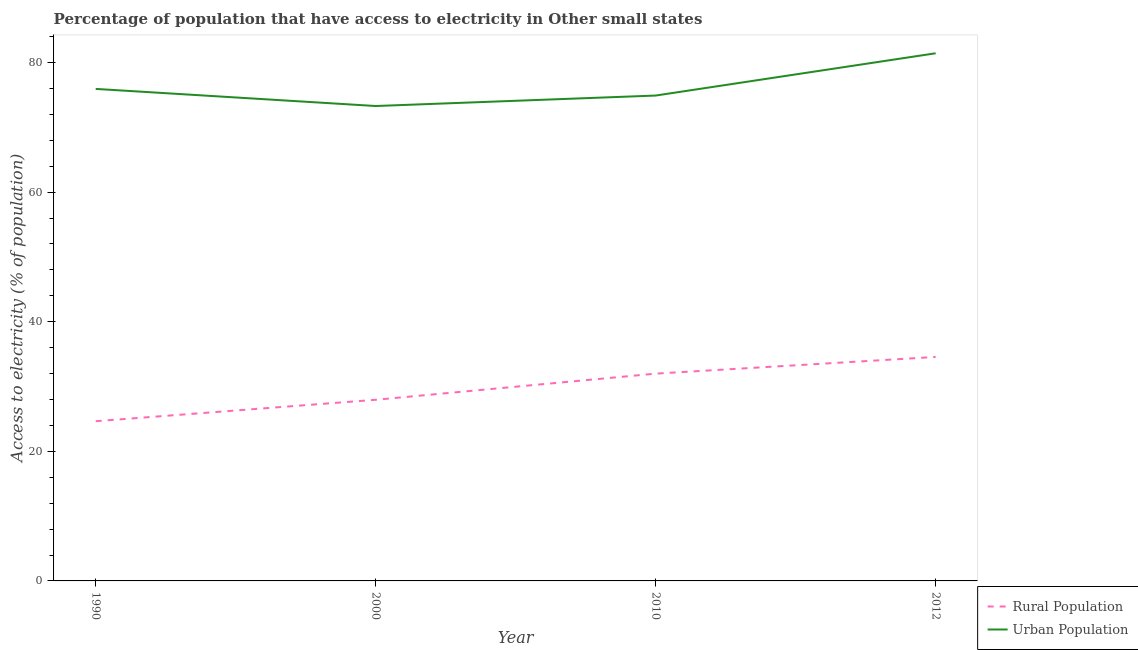Does the line corresponding to percentage of rural population having access to electricity intersect with the line corresponding to percentage of urban population having access to electricity?
Provide a succinct answer. No. Is the number of lines equal to the number of legend labels?
Ensure brevity in your answer.  Yes. What is the percentage of urban population having access to electricity in 2012?
Provide a succinct answer. 81.43. Across all years, what is the maximum percentage of rural population having access to electricity?
Provide a short and direct response. 34.57. Across all years, what is the minimum percentage of urban population having access to electricity?
Your answer should be very brief. 73.29. What is the total percentage of urban population having access to electricity in the graph?
Give a very brief answer. 305.56. What is the difference between the percentage of urban population having access to electricity in 1990 and that in 2010?
Give a very brief answer. 1.02. What is the difference between the percentage of urban population having access to electricity in 1990 and the percentage of rural population having access to electricity in 2012?
Provide a succinct answer. 41.36. What is the average percentage of urban population having access to electricity per year?
Offer a terse response. 76.39. In the year 2010, what is the difference between the percentage of rural population having access to electricity and percentage of urban population having access to electricity?
Your answer should be very brief. -42.92. What is the ratio of the percentage of urban population having access to electricity in 2000 to that in 2012?
Provide a short and direct response. 0.9. What is the difference between the highest and the second highest percentage of rural population having access to electricity?
Your answer should be very brief. 2.58. What is the difference between the highest and the lowest percentage of rural population having access to electricity?
Provide a succinct answer. 9.92. In how many years, is the percentage of rural population having access to electricity greater than the average percentage of rural population having access to electricity taken over all years?
Keep it short and to the point. 2. Is the sum of the percentage of rural population having access to electricity in 1990 and 2012 greater than the maximum percentage of urban population having access to electricity across all years?
Give a very brief answer. No. Does the percentage of urban population having access to electricity monotonically increase over the years?
Provide a succinct answer. No. Is the percentage of urban population having access to electricity strictly greater than the percentage of rural population having access to electricity over the years?
Ensure brevity in your answer.  Yes. Is the percentage of urban population having access to electricity strictly less than the percentage of rural population having access to electricity over the years?
Your answer should be compact. No. Does the graph contain any zero values?
Your answer should be compact. No. Does the graph contain grids?
Your answer should be compact. No. How many legend labels are there?
Your answer should be very brief. 2. How are the legend labels stacked?
Your answer should be very brief. Vertical. What is the title of the graph?
Provide a succinct answer. Percentage of population that have access to electricity in Other small states. What is the label or title of the Y-axis?
Your answer should be compact. Access to electricity (% of population). What is the Access to electricity (% of population) of Rural Population in 1990?
Provide a succinct answer. 24.65. What is the Access to electricity (% of population) of Urban Population in 1990?
Offer a very short reply. 75.93. What is the Access to electricity (% of population) in Rural Population in 2000?
Keep it short and to the point. 27.96. What is the Access to electricity (% of population) in Urban Population in 2000?
Give a very brief answer. 73.29. What is the Access to electricity (% of population) of Rural Population in 2010?
Keep it short and to the point. 31.99. What is the Access to electricity (% of population) of Urban Population in 2010?
Your response must be concise. 74.91. What is the Access to electricity (% of population) of Rural Population in 2012?
Keep it short and to the point. 34.57. What is the Access to electricity (% of population) in Urban Population in 2012?
Keep it short and to the point. 81.43. Across all years, what is the maximum Access to electricity (% of population) in Rural Population?
Ensure brevity in your answer.  34.57. Across all years, what is the maximum Access to electricity (% of population) of Urban Population?
Provide a succinct answer. 81.43. Across all years, what is the minimum Access to electricity (% of population) in Rural Population?
Make the answer very short. 24.65. Across all years, what is the minimum Access to electricity (% of population) of Urban Population?
Provide a short and direct response. 73.29. What is the total Access to electricity (% of population) of Rural Population in the graph?
Ensure brevity in your answer.  119.16. What is the total Access to electricity (% of population) in Urban Population in the graph?
Keep it short and to the point. 305.56. What is the difference between the Access to electricity (% of population) of Rural Population in 1990 and that in 2000?
Provide a short and direct response. -3.31. What is the difference between the Access to electricity (% of population) of Urban Population in 1990 and that in 2000?
Your response must be concise. 2.64. What is the difference between the Access to electricity (% of population) in Rural Population in 1990 and that in 2010?
Your answer should be very brief. -7.34. What is the difference between the Access to electricity (% of population) of Urban Population in 1990 and that in 2010?
Offer a terse response. 1.02. What is the difference between the Access to electricity (% of population) in Rural Population in 1990 and that in 2012?
Your answer should be compact. -9.92. What is the difference between the Access to electricity (% of population) of Urban Population in 1990 and that in 2012?
Your answer should be compact. -5.5. What is the difference between the Access to electricity (% of population) in Rural Population in 2000 and that in 2010?
Provide a short and direct response. -4.04. What is the difference between the Access to electricity (% of population) in Urban Population in 2000 and that in 2010?
Make the answer very short. -1.62. What is the difference between the Access to electricity (% of population) of Rural Population in 2000 and that in 2012?
Give a very brief answer. -6.61. What is the difference between the Access to electricity (% of population) in Urban Population in 2000 and that in 2012?
Keep it short and to the point. -8.14. What is the difference between the Access to electricity (% of population) in Rural Population in 2010 and that in 2012?
Keep it short and to the point. -2.58. What is the difference between the Access to electricity (% of population) of Urban Population in 2010 and that in 2012?
Provide a short and direct response. -6.52. What is the difference between the Access to electricity (% of population) in Rural Population in 1990 and the Access to electricity (% of population) in Urban Population in 2000?
Provide a succinct answer. -48.64. What is the difference between the Access to electricity (% of population) of Rural Population in 1990 and the Access to electricity (% of population) of Urban Population in 2010?
Provide a short and direct response. -50.26. What is the difference between the Access to electricity (% of population) in Rural Population in 1990 and the Access to electricity (% of population) in Urban Population in 2012?
Give a very brief answer. -56.78. What is the difference between the Access to electricity (% of population) of Rural Population in 2000 and the Access to electricity (% of population) of Urban Population in 2010?
Offer a very short reply. -46.95. What is the difference between the Access to electricity (% of population) of Rural Population in 2000 and the Access to electricity (% of population) of Urban Population in 2012?
Keep it short and to the point. -53.48. What is the difference between the Access to electricity (% of population) in Rural Population in 2010 and the Access to electricity (% of population) in Urban Population in 2012?
Offer a very short reply. -49.44. What is the average Access to electricity (% of population) of Rural Population per year?
Your answer should be very brief. 29.79. What is the average Access to electricity (% of population) in Urban Population per year?
Keep it short and to the point. 76.39. In the year 1990, what is the difference between the Access to electricity (% of population) of Rural Population and Access to electricity (% of population) of Urban Population?
Give a very brief answer. -51.28. In the year 2000, what is the difference between the Access to electricity (% of population) of Rural Population and Access to electricity (% of population) of Urban Population?
Make the answer very short. -45.34. In the year 2010, what is the difference between the Access to electricity (% of population) in Rural Population and Access to electricity (% of population) in Urban Population?
Make the answer very short. -42.92. In the year 2012, what is the difference between the Access to electricity (% of population) in Rural Population and Access to electricity (% of population) in Urban Population?
Offer a terse response. -46.86. What is the ratio of the Access to electricity (% of population) in Rural Population in 1990 to that in 2000?
Offer a very short reply. 0.88. What is the ratio of the Access to electricity (% of population) of Urban Population in 1990 to that in 2000?
Give a very brief answer. 1.04. What is the ratio of the Access to electricity (% of population) in Rural Population in 1990 to that in 2010?
Ensure brevity in your answer.  0.77. What is the ratio of the Access to electricity (% of population) in Urban Population in 1990 to that in 2010?
Keep it short and to the point. 1.01. What is the ratio of the Access to electricity (% of population) of Rural Population in 1990 to that in 2012?
Your answer should be very brief. 0.71. What is the ratio of the Access to electricity (% of population) in Urban Population in 1990 to that in 2012?
Your answer should be compact. 0.93. What is the ratio of the Access to electricity (% of population) in Rural Population in 2000 to that in 2010?
Your response must be concise. 0.87. What is the ratio of the Access to electricity (% of population) of Urban Population in 2000 to that in 2010?
Keep it short and to the point. 0.98. What is the ratio of the Access to electricity (% of population) in Rural Population in 2000 to that in 2012?
Your answer should be compact. 0.81. What is the ratio of the Access to electricity (% of population) of Urban Population in 2000 to that in 2012?
Keep it short and to the point. 0.9. What is the ratio of the Access to electricity (% of population) of Rural Population in 2010 to that in 2012?
Your answer should be compact. 0.93. What is the ratio of the Access to electricity (% of population) in Urban Population in 2010 to that in 2012?
Provide a succinct answer. 0.92. What is the difference between the highest and the second highest Access to electricity (% of population) in Rural Population?
Provide a succinct answer. 2.58. What is the difference between the highest and the second highest Access to electricity (% of population) of Urban Population?
Your answer should be compact. 5.5. What is the difference between the highest and the lowest Access to electricity (% of population) of Rural Population?
Your answer should be compact. 9.92. What is the difference between the highest and the lowest Access to electricity (% of population) in Urban Population?
Keep it short and to the point. 8.14. 